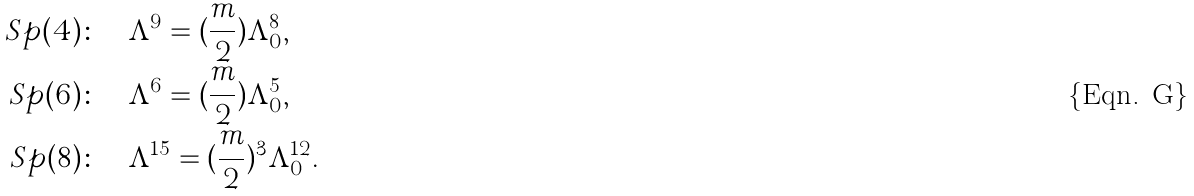<formula> <loc_0><loc_0><loc_500><loc_500>S p ( 4 ) \colon & \quad \Lambda ^ { 9 } = ( \frac { m } { 2 } ) \Lambda _ { 0 } ^ { 8 } , \\ S p ( 6 ) \colon & \quad \Lambda ^ { 6 } = ( \frac { m } { 2 } ) \Lambda _ { 0 } ^ { 5 } , \\ S p ( 8 ) \colon & \quad \Lambda ^ { 1 5 } = ( \frac { m } { 2 } ) ^ { 3 } \Lambda _ { 0 } ^ { 1 2 } .</formula> 